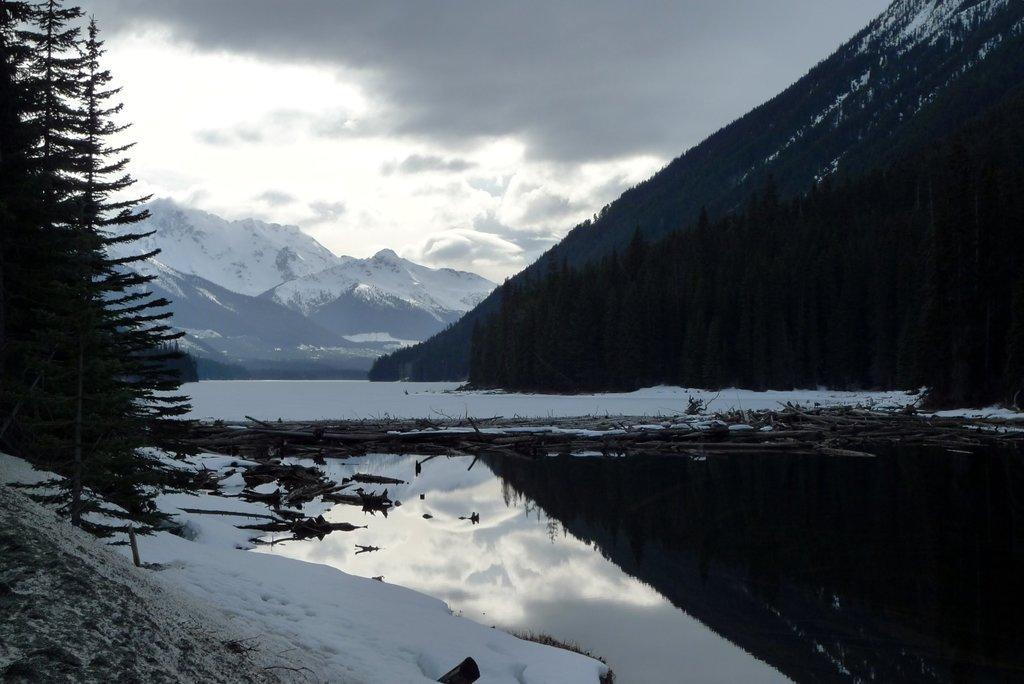Describe this image in one or two sentences. This is an outside view. At the bottom, I can see the water and snow on the ground. On the right and left side of the image there are many trees. In the background there are few mountains. At the top of the image I can see the sky and clouds. 